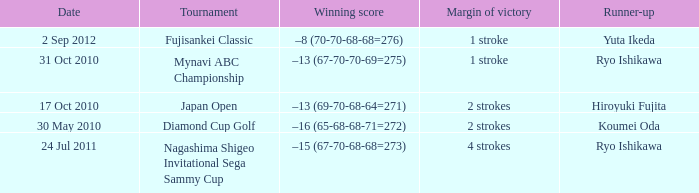Who was the Japan open runner up? Hiroyuki Fujita. Would you be able to parse every entry in this table? {'header': ['Date', 'Tournament', 'Winning score', 'Margin of victory', 'Runner-up'], 'rows': [['2 Sep 2012', 'Fujisankei Classic', '–8 (70-70-68-68=276)', '1 stroke', 'Yuta Ikeda'], ['31 Oct 2010', 'Mynavi ABC Championship', '–13 (67-70-70-69=275)', '1 stroke', 'Ryo Ishikawa'], ['17 Oct 2010', 'Japan Open', '–13 (69-70-68-64=271)', '2 strokes', 'Hiroyuki Fujita'], ['30 May 2010', 'Diamond Cup Golf', '–16 (65-68-68-71=272)', '2 strokes', 'Koumei Oda'], ['24 Jul 2011', 'Nagashima Shigeo Invitational Sega Sammy Cup', '–15 (67-70-68-68=273)', '4 strokes', 'Ryo Ishikawa']]} 